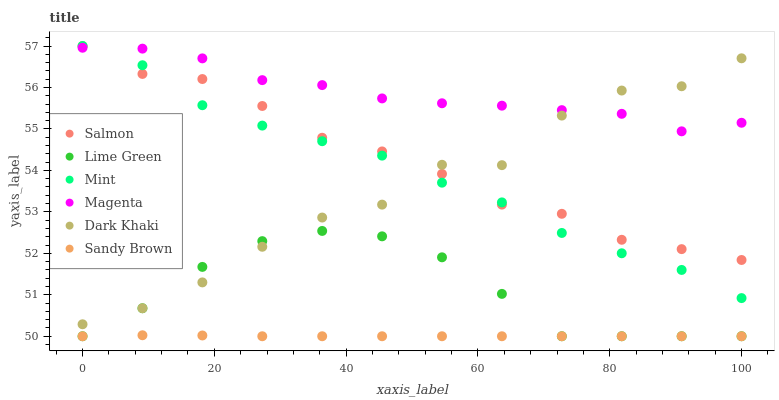Does Sandy Brown have the minimum area under the curve?
Answer yes or no. Yes. Does Magenta have the maximum area under the curve?
Answer yes or no. Yes. Does Mint have the minimum area under the curve?
Answer yes or no. No. Does Mint have the maximum area under the curve?
Answer yes or no. No. Is Sandy Brown the smoothest?
Answer yes or no. Yes. Is Dark Khaki the roughest?
Answer yes or no. Yes. Is Mint the smoothest?
Answer yes or no. No. Is Mint the roughest?
Answer yes or no. No. Does Sandy Brown have the lowest value?
Answer yes or no. Yes. Does Mint have the lowest value?
Answer yes or no. No. Does Salmon have the highest value?
Answer yes or no. Yes. Does Dark Khaki have the highest value?
Answer yes or no. No. Is Lime Green less than Mint?
Answer yes or no. Yes. Is Mint greater than Lime Green?
Answer yes or no. Yes. Does Mint intersect Magenta?
Answer yes or no. Yes. Is Mint less than Magenta?
Answer yes or no. No. Is Mint greater than Magenta?
Answer yes or no. No. Does Lime Green intersect Mint?
Answer yes or no. No. 